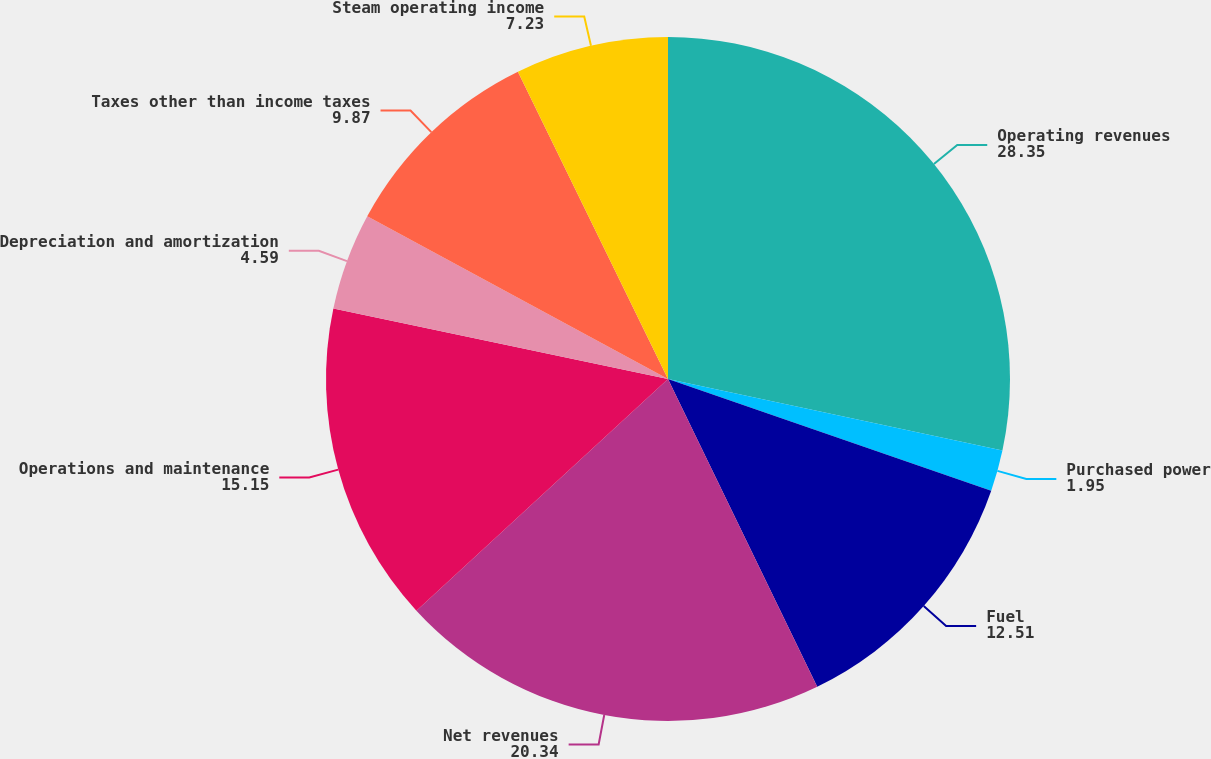Convert chart to OTSL. <chart><loc_0><loc_0><loc_500><loc_500><pie_chart><fcel>Operating revenues<fcel>Purchased power<fcel>Fuel<fcel>Net revenues<fcel>Operations and maintenance<fcel>Depreciation and amortization<fcel>Taxes other than income taxes<fcel>Steam operating income<nl><fcel>28.35%<fcel>1.95%<fcel>12.51%<fcel>20.34%<fcel>15.15%<fcel>4.59%<fcel>9.87%<fcel>7.23%<nl></chart> 